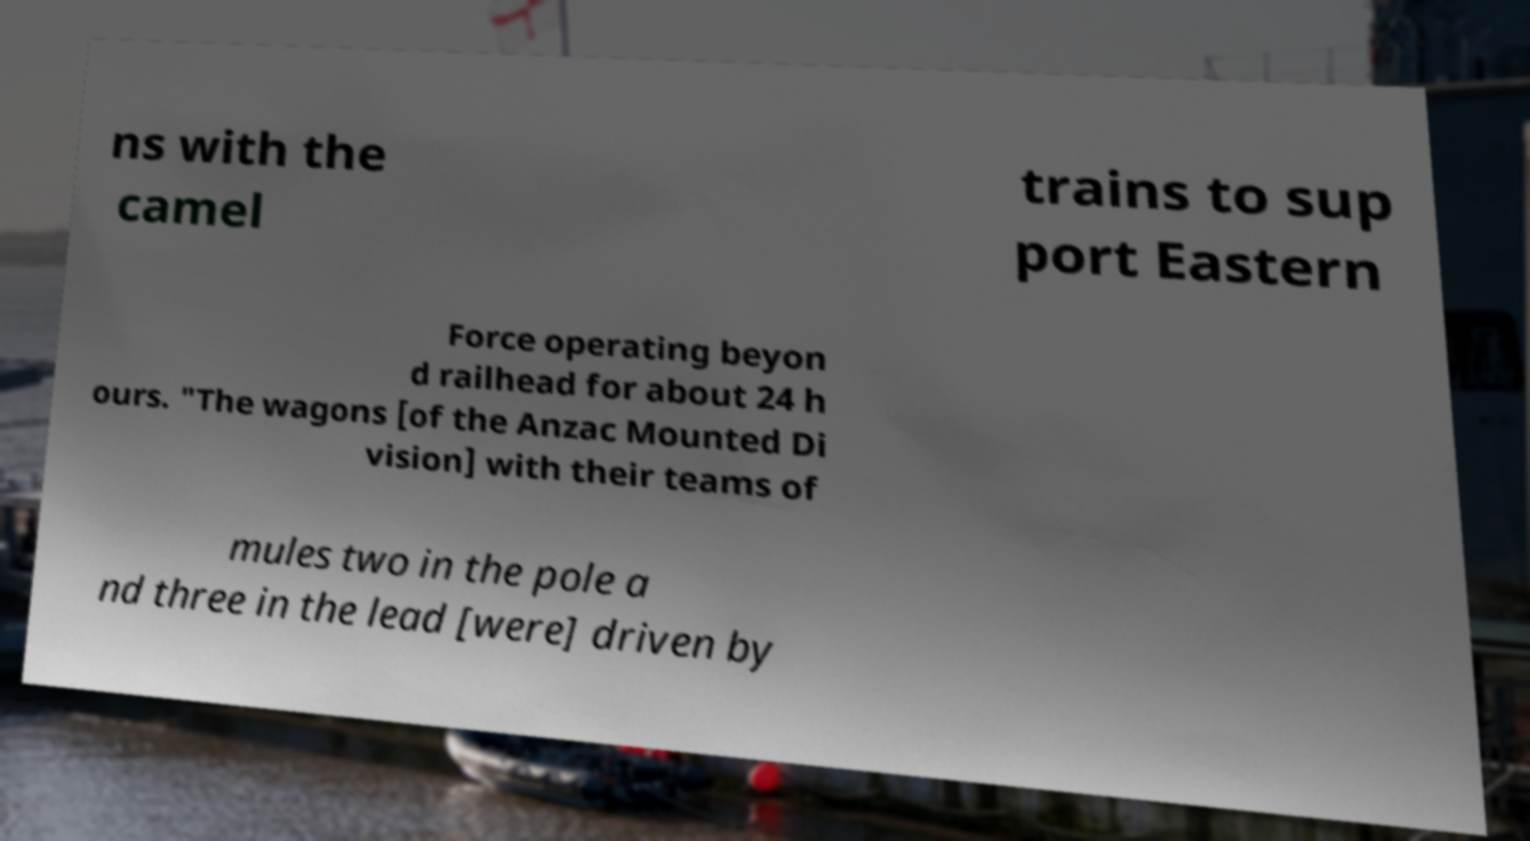Could you extract and type out the text from this image? ns with the camel trains to sup port Eastern Force operating beyon d railhead for about 24 h ours. "The wagons [of the Anzac Mounted Di vision] with their teams of mules two in the pole a nd three in the lead [were] driven by 